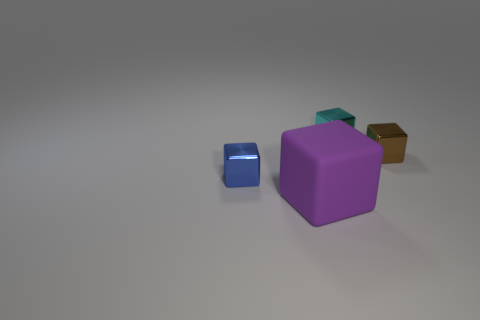Can you tell me the colors of the blocks in the image? Certainly, there are four blocks in the image. Starting with the largest, we have a purple block, followed by a teal block, a brown block, and finally a blue block, which is the smallest. 